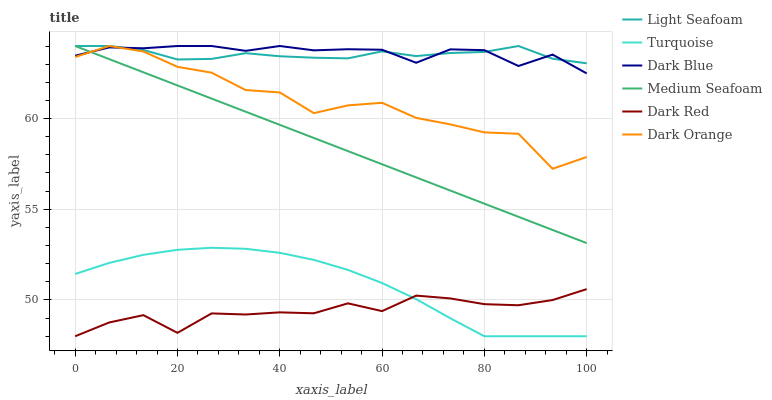Does Dark Red have the minimum area under the curve?
Answer yes or no. Yes. Does Dark Blue have the maximum area under the curve?
Answer yes or no. Yes. Does Turquoise have the minimum area under the curve?
Answer yes or no. No. Does Turquoise have the maximum area under the curve?
Answer yes or no. No. Is Medium Seafoam the smoothest?
Answer yes or no. Yes. Is Dark Orange the roughest?
Answer yes or no. Yes. Is Turquoise the smoothest?
Answer yes or no. No. Is Turquoise the roughest?
Answer yes or no. No. Does Dark Blue have the lowest value?
Answer yes or no. No. Does Medium Seafoam have the highest value?
Answer yes or no. Yes. Does Turquoise have the highest value?
Answer yes or no. No. Is Turquoise less than Light Seafoam?
Answer yes or no. Yes. Is Medium Seafoam greater than Turquoise?
Answer yes or no. Yes. Does Light Seafoam intersect Dark Blue?
Answer yes or no. Yes. Is Light Seafoam less than Dark Blue?
Answer yes or no. No. Is Light Seafoam greater than Dark Blue?
Answer yes or no. No. Does Turquoise intersect Light Seafoam?
Answer yes or no. No. 